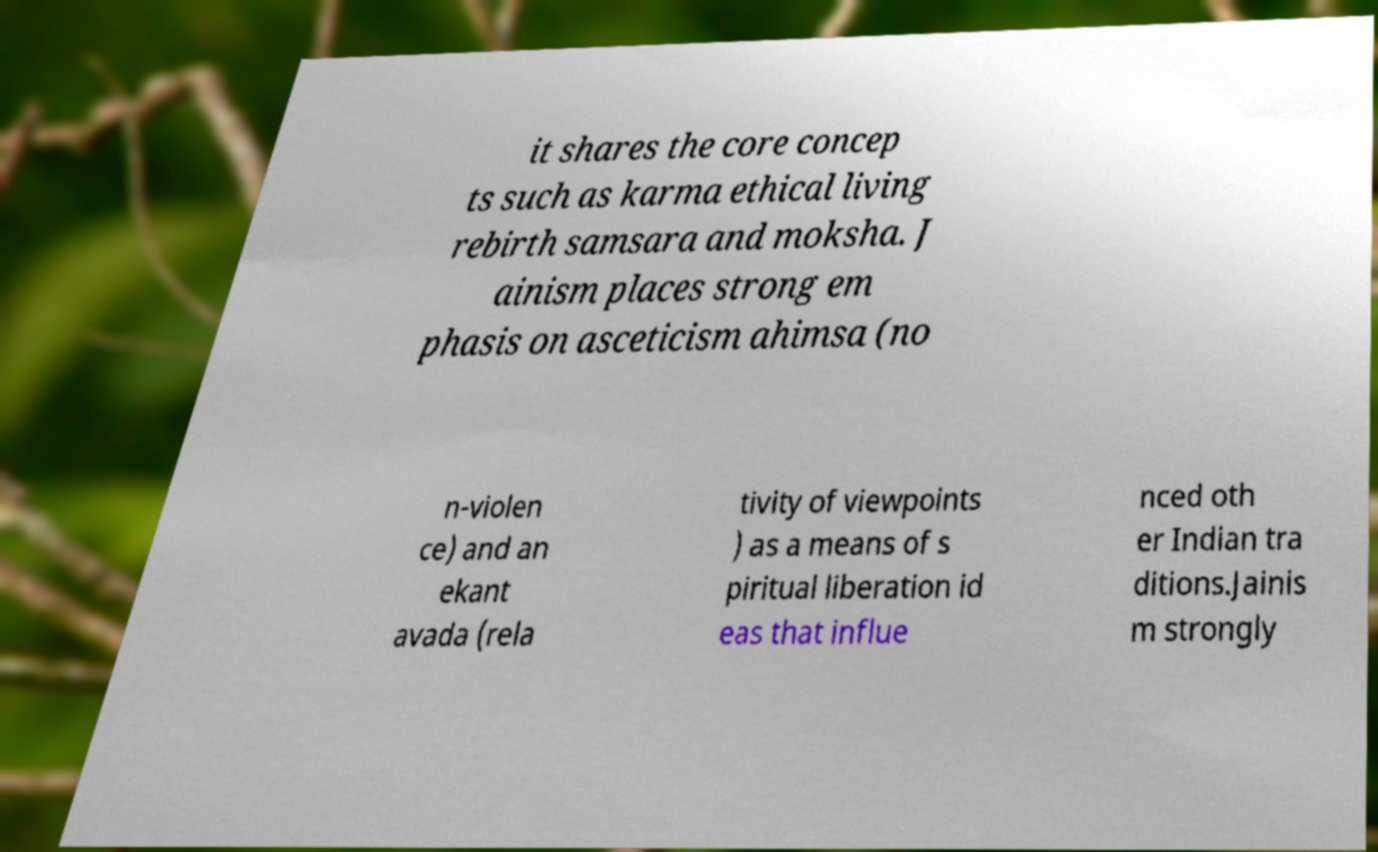Could you assist in decoding the text presented in this image and type it out clearly? it shares the core concep ts such as karma ethical living rebirth samsara and moksha. J ainism places strong em phasis on asceticism ahimsa (no n-violen ce) and an ekant avada (rela tivity of viewpoints ) as a means of s piritual liberation id eas that influe nced oth er Indian tra ditions.Jainis m strongly 